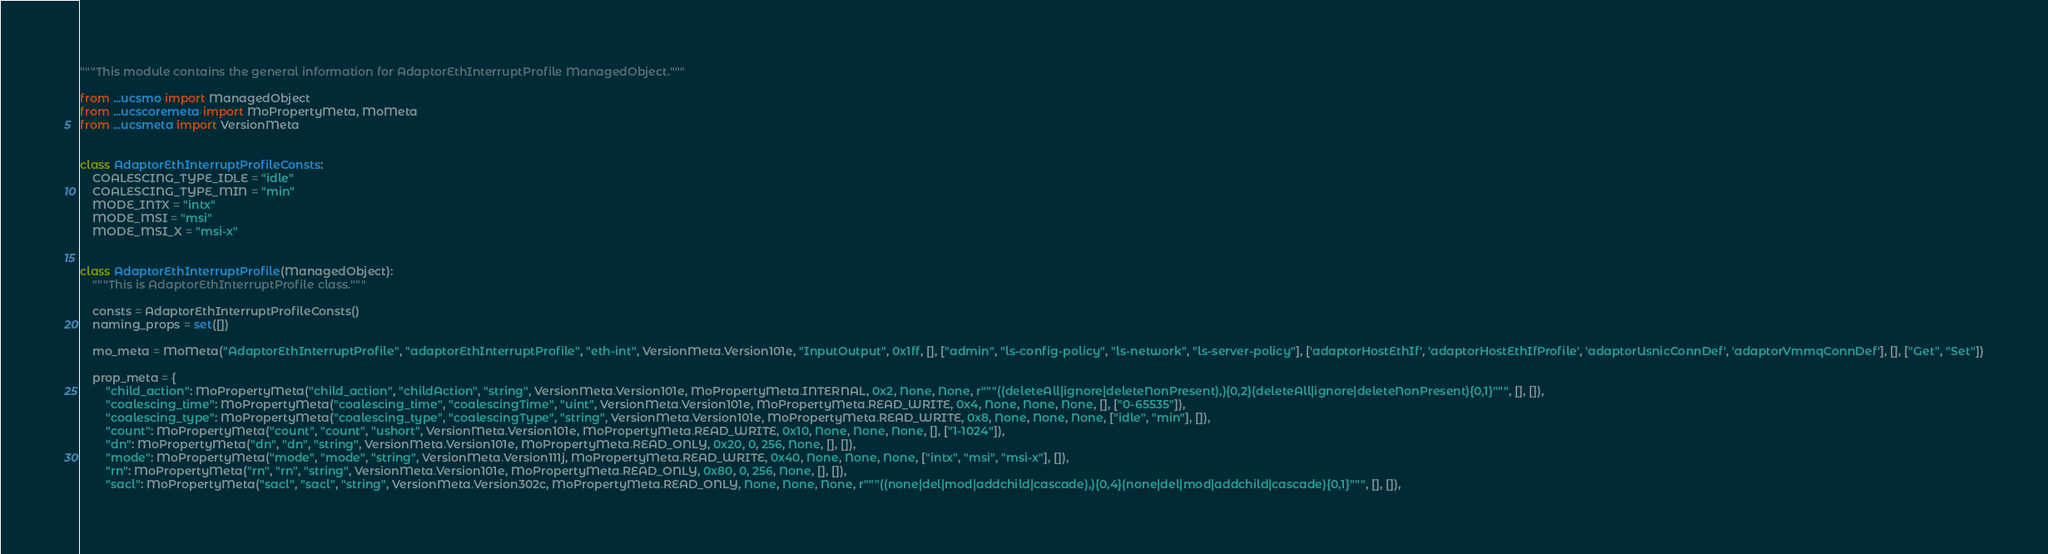Convert code to text. <code><loc_0><loc_0><loc_500><loc_500><_Python_>"""This module contains the general information for AdaptorEthInterruptProfile ManagedObject."""

from ...ucsmo import ManagedObject
from ...ucscoremeta import MoPropertyMeta, MoMeta
from ...ucsmeta import VersionMeta


class AdaptorEthInterruptProfileConsts:
    COALESCING_TYPE_IDLE = "idle"
    COALESCING_TYPE_MIN = "min"
    MODE_INTX = "intx"
    MODE_MSI = "msi"
    MODE_MSI_X = "msi-x"


class AdaptorEthInterruptProfile(ManagedObject):
    """This is AdaptorEthInterruptProfile class."""

    consts = AdaptorEthInterruptProfileConsts()
    naming_props = set([])

    mo_meta = MoMeta("AdaptorEthInterruptProfile", "adaptorEthInterruptProfile", "eth-int", VersionMeta.Version101e, "InputOutput", 0x1ff, [], ["admin", "ls-config-policy", "ls-network", "ls-server-policy"], ['adaptorHostEthIf', 'adaptorHostEthIfProfile', 'adaptorUsnicConnDef', 'adaptorVmmqConnDef'], [], ["Get", "Set"])

    prop_meta = {
        "child_action": MoPropertyMeta("child_action", "childAction", "string", VersionMeta.Version101e, MoPropertyMeta.INTERNAL, 0x2, None, None, r"""((deleteAll|ignore|deleteNonPresent),){0,2}(deleteAll|ignore|deleteNonPresent){0,1}""", [], []),
        "coalescing_time": MoPropertyMeta("coalescing_time", "coalescingTime", "uint", VersionMeta.Version101e, MoPropertyMeta.READ_WRITE, 0x4, None, None, None, [], ["0-65535"]),
        "coalescing_type": MoPropertyMeta("coalescing_type", "coalescingType", "string", VersionMeta.Version101e, MoPropertyMeta.READ_WRITE, 0x8, None, None, None, ["idle", "min"], []),
        "count": MoPropertyMeta("count", "count", "ushort", VersionMeta.Version101e, MoPropertyMeta.READ_WRITE, 0x10, None, None, None, [], ["1-1024"]),
        "dn": MoPropertyMeta("dn", "dn", "string", VersionMeta.Version101e, MoPropertyMeta.READ_ONLY, 0x20, 0, 256, None, [], []),
        "mode": MoPropertyMeta("mode", "mode", "string", VersionMeta.Version111j, MoPropertyMeta.READ_WRITE, 0x40, None, None, None, ["intx", "msi", "msi-x"], []),
        "rn": MoPropertyMeta("rn", "rn", "string", VersionMeta.Version101e, MoPropertyMeta.READ_ONLY, 0x80, 0, 256, None, [], []),
        "sacl": MoPropertyMeta("sacl", "sacl", "string", VersionMeta.Version302c, MoPropertyMeta.READ_ONLY, None, None, None, r"""((none|del|mod|addchild|cascade),){0,4}(none|del|mod|addchild|cascade){0,1}""", [], []),</code> 